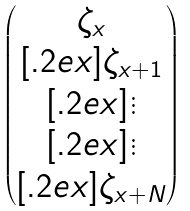Convert formula to latex. <formula><loc_0><loc_0><loc_500><loc_500>\begin{pmatrix} \zeta _ { x } \\ [ . 2 e x ] \zeta _ { x + 1 } \\ [ . 2 e x ] \vdots \\ [ . 2 e x ] \vdots \\ [ . 2 e x ] \zeta _ { x + N } \end{pmatrix}</formula> 